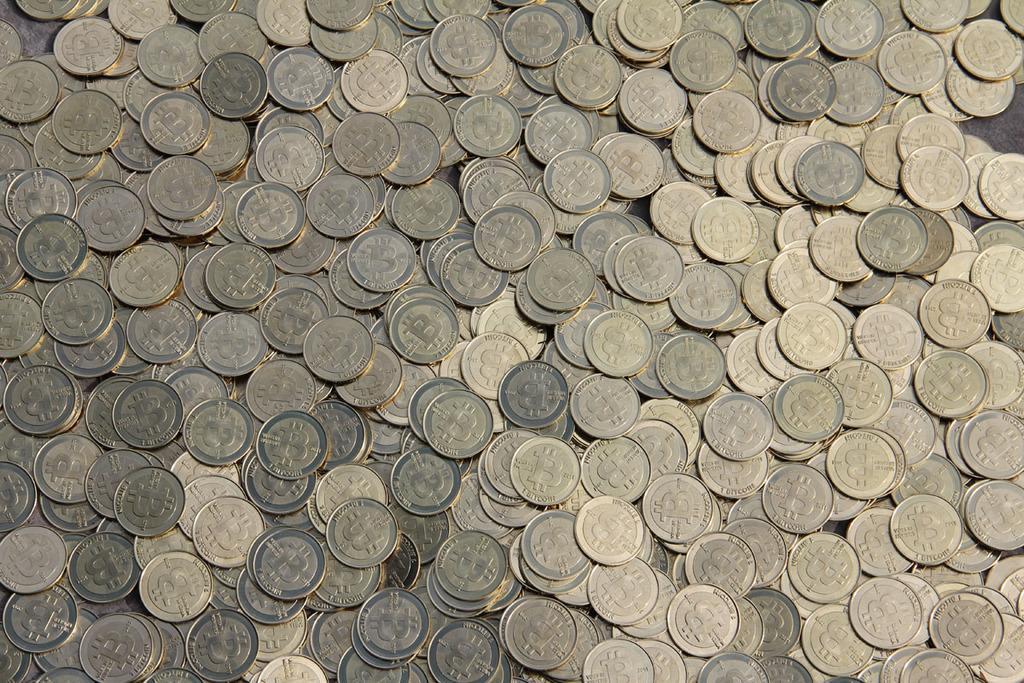Could you give a brief overview of what you see in this image? There are coins in this image. 